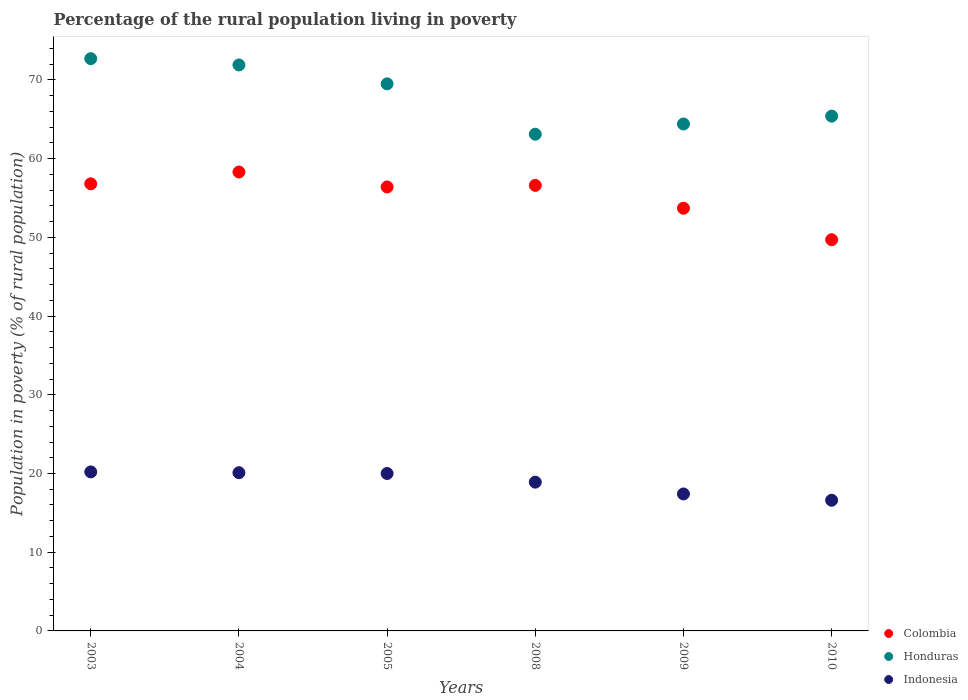How many different coloured dotlines are there?
Your answer should be very brief. 3. Is the number of dotlines equal to the number of legend labels?
Your response must be concise. Yes. Across all years, what is the maximum percentage of the rural population living in poverty in Colombia?
Keep it short and to the point. 58.3. Across all years, what is the minimum percentage of the rural population living in poverty in Colombia?
Ensure brevity in your answer.  49.7. In which year was the percentage of the rural population living in poverty in Honduras maximum?
Ensure brevity in your answer.  2003. In which year was the percentage of the rural population living in poverty in Colombia minimum?
Provide a succinct answer. 2010. What is the total percentage of the rural population living in poverty in Indonesia in the graph?
Your answer should be compact. 113.2. What is the difference between the percentage of the rural population living in poverty in Honduras in 2003 and that in 2004?
Offer a very short reply. 0.8. What is the difference between the percentage of the rural population living in poverty in Honduras in 2005 and the percentage of the rural population living in poverty in Indonesia in 2008?
Your answer should be very brief. 50.6. What is the average percentage of the rural population living in poverty in Colombia per year?
Your answer should be compact. 55.25. In the year 2008, what is the difference between the percentage of the rural population living in poverty in Indonesia and percentage of the rural population living in poverty in Colombia?
Keep it short and to the point. -37.7. In how many years, is the percentage of the rural population living in poverty in Honduras greater than 2 %?
Offer a terse response. 6. What is the ratio of the percentage of the rural population living in poverty in Indonesia in 2004 to that in 2009?
Your answer should be compact. 1.16. Is the percentage of the rural population living in poverty in Colombia in 2004 less than that in 2009?
Provide a succinct answer. No. What is the difference between the highest and the second highest percentage of the rural population living in poverty in Honduras?
Your answer should be compact. 0.8. What is the difference between the highest and the lowest percentage of the rural population living in poverty in Colombia?
Keep it short and to the point. 8.6. Is the sum of the percentage of the rural population living in poverty in Colombia in 2004 and 2008 greater than the maximum percentage of the rural population living in poverty in Honduras across all years?
Offer a very short reply. Yes. Is it the case that in every year, the sum of the percentage of the rural population living in poverty in Indonesia and percentage of the rural population living in poverty in Honduras  is greater than the percentage of the rural population living in poverty in Colombia?
Your answer should be compact. Yes. Does the percentage of the rural population living in poverty in Honduras monotonically increase over the years?
Provide a succinct answer. No. Is the percentage of the rural population living in poverty in Indonesia strictly greater than the percentage of the rural population living in poverty in Honduras over the years?
Make the answer very short. No. How many dotlines are there?
Offer a terse response. 3. Does the graph contain any zero values?
Ensure brevity in your answer.  No. Where does the legend appear in the graph?
Your response must be concise. Bottom right. What is the title of the graph?
Give a very brief answer. Percentage of the rural population living in poverty. Does "Albania" appear as one of the legend labels in the graph?
Offer a very short reply. No. What is the label or title of the Y-axis?
Your answer should be compact. Population in poverty (% of rural population). What is the Population in poverty (% of rural population) of Colombia in 2003?
Offer a very short reply. 56.8. What is the Population in poverty (% of rural population) in Honduras in 2003?
Your answer should be very brief. 72.7. What is the Population in poverty (% of rural population) of Indonesia in 2003?
Your response must be concise. 20.2. What is the Population in poverty (% of rural population) in Colombia in 2004?
Make the answer very short. 58.3. What is the Population in poverty (% of rural population) in Honduras in 2004?
Provide a succinct answer. 71.9. What is the Population in poverty (% of rural population) in Indonesia in 2004?
Keep it short and to the point. 20.1. What is the Population in poverty (% of rural population) in Colombia in 2005?
Provide a succinct answer. 56.4. What is the Population in poverty (% of rural population) of Honduras in 2005?
Your answer should be very brief. 69.5. What is the Population in poverty (% of rural population) of Colombia in 2008?
Your answer should be compact. 56.6. What is the Population in poverty (% of rural population) of Honduras in 2008?
Offer a terse response. 63.1. What is the Population in poverty (% of rural population) in Indonesia in 2008?
Your answer should be very brief. 18.9. What is the Population in poverty (% of rural population) in Colombia in 2009?
Provide a short and direct response. 53.7. What is the Population in poverty (% of rural population) in Honduras in 2009?
Keep it short and to the point. 64.4. What is the Population in poverty (% of rural population) in Indonesia in 2009?
Provide a short and direct response. 17.4. What is the Population in poverty (% of rural population) in Colombia in 2010?
Keep it short and to the point. 49.7. What is the Population in poverty (% of rural population) of Honduras in 2010?
Your answer should be very brief. 65.4. Across all years, what is the maximum Population in poverty (% of rural population) of Colombia?
Your response must be concise. 58.3. Across all years, what is the maximum Population in poverty (% of rural population) in Honduras?
Make the answer very short. 72.7. Across all years, what is the maximum Population in poverty (% of rural population) in Indonesia?
Give a very brief answer. 20.2. Across all years, what is the minimum Population in poverty (% of rural population) of Colombia?
Ensure brevity in your answer.  49.7. Across all years, what is the minimum Population in poverty (% of rural population) of Honduras?
Your answer should be very brief. 63.1. What is the total Population in poverty (% of rural population) in Colombia in the graph?
Keep it short and to the point. 331.5. What is the total Population in poverty (% of rural population) in Honduras in the graph?
Provide a short and direct response. 407. What is the total Population in poverty (% of rural population) in Indonesia in the graph?
Keep it short and to the point. 113.2. What is the difference between the Population in poverty (% of rural population) in Honduras in 2003 and that in 2004?
Your answer should be compact. 0.8. What is the difference between the Population in poverty (% of rural population) of Indonesia in 2003 and that in 2004?
Provide a short and direct response. 0.1. What is the difference between the Population in poverty (% of rural population) of Colombia in 2003 and that in 2005?
Offer a very short reply. 0.4. What is the difference between the Population in poverty (% of rural population) of Honduras in 2003 and that in 2005?
Offer a terse response. 3.2. What is the difference between the Population in poverty (% of rural population) of Honduras in 2003 and that in 2009?
Your response must be concise. 8.3. What is the difference between the Population in poverty (% of rural population) of Honduras in 2004 and that in 2005?
Provide a short and direct response. 2.4. What is the difference between the Population in poverty (% of rural population) in Indonesia in 2004 and that in 2005?
Ensure brevity in your answer.  0.1. What is the difference between the Population in poverty (% of rural population) in Colombia in 2004 and that in 2008?
Your answer should be very brief. 1.7. What is the difference between the Population in poverty (% of rural population) in Colombia in 2004 and that in 2009?
Ensure brevity in your answer.  4.6. What is the difference between the Population in poverty (% of rural population) of Indonesia in 2004 and that in 2010?
Your answer should be very brief. 3.5. What is the difference between the Population in poverty (% of rural population) in Honduras in 2005 and that in 2008?
Provide a succinct answer. 6.4. What is the difference between the Population in poverty (% of rural population) of Indonesia in 2005 and that in 2008?
Make the answer very short. 1.1. What is the difference between the Population in poverty (% of rural population) of Honduras in 2005 and that in 2009?
Your response must be concise. 5.1. What is the difference between the Population in poverty (% of rural population) of Indonesia in 2005 and that in 2009?
Offer a very short reply. 2.6. What is the difference between the Population in poverty (% of rural population) in Colombia in 2005 and that in 2010?
Ensure brevity in your answer.  6.7. What is the difference between the Population in poverty (% of rural population) in Honduras in 2005 and that in 2010?
Provide a succinct answer. 4.1. What is the difference between the Population in poverty (% of rural population) in Honduras in 2008 and that in 2010?
Offer a very short reply. -2.3. What is the difference between the Population in poverty (% of rural population) in Colombia in 2009 and that in 2010?
Your answer should be compact. 4. What is the difference between the Population in poverty (% of rural population) of Colombia in 2003 and the Population in poverty (% of rural population) of Honduras in 2004?
Give a very brief answer. -15.1. What is the difference between the Population in poverty (% of rural population) in Colombia in 2003 and the Population in poverty (% of rural population) in Indonesia in 2004?
Ensure brevity in your answer.  36.7. What is the difference between the Population in poverty (% of rural population) in Honduras in 2003 and the Population in poverty (% of rural population) in Indonesia in 2004?
Make the answer very short. 52.6. What is the difference between the Population in poverty (% of rural population) in Colombia in 2003 and the Population in poverty (% of rural population) in Honduras in 2005?
Make the answer very short. -12.7. What is the difference between the Population in poverty (% of rural population) in Colombia in 2003 and the Population in poverty (% of rural population) in Indonesia in 2005?
Offer a terse response. 36.8. What is the difference between the Population in poverty (% of rural population) in Honduras in 2003 and the Population in poverty (% of rural population) in Indonesia in 2005?
Ensure brevity in your answer.  52.7. What is the difference between the Population in poverty (% of rural population) of Colombia in 2003 and the Population in poverty (% of rural population) of Indonesia in 2008?
Make the answer very short. 37.9. What is the difference between the Population in poverty (% of rural population) in Honduras in 2003 and the Population in poverty (% of rural population) in Indonesia in 2008?
Keep it short and to the point. 53.8. What is the difference between the Population in poverty (% of rural population) in Colombia in 2003 and the Population in poverty (% of rural population) in Indonesia in 2009?
Provide a short and direct response. 39.4. What is the difference between the Population in poverty (% of rural population) in Honduras in 2003 and the Population in poverty (% of rural population) in Indonesia in 2009?
Keep it short and to the point. 55.3. What is the difference between the Population in poverty (% of rural population) of Colombia in 2003 and the Population in poverty (% of rural population) of Honduras in 2010?
Keep it short and to the point. -8.6. What is the difference between the Population in poverty (% of rural population) of Colombia in 2003 and the Population in poverty (% of rural population) of Indonesia in 2010?
Provide a short and direct response. 40.2. What is the difference between the Population in poverty (% of rural population) in Honduras in 2003 and the Population in poverty (% of rural population) in Indonesia in 2010?
Keep it short and to the point. 56.1. What is the difference between the Population in poverty (% of rural population) of Colombia in 2004 and the Population in poverty (% of rural population) of Indonesia in 2005?
Your response must be concise. 38.3. What is the difference between the Population in poverty (% of rural population) in Honduras in 2004 and the Population in poverty (% of rural population) in Indonesia in 2005?
Provide a succinct answer. 51.9. What is the difference between the Population in poverty (% of rural population) in Colombia in 2004 and the Population in poverty (% of rural population) in Honduras in 2008?
Provide a succinct answer. -4.8. What is the difference between the Population in poverty (% of rural population) in Colombia in 2004 and the Population in poverty (% of rural population) in Indonesia in 2008?
Your answer should be very brief. 39.4. What is the difference between the Population in poverty (% of rural population) in Colombia in 2004 and the Population in poverty (% of rural population) in Indonesia in 2009?
Offer a terse response. 40.9. What is the difference between the Population in poverty (% of rural population) of Honduras in 2004 and the Population in poverty (% of rural population) of Indonesia in 2009?
Provide a succinct answer. 54.5. What is the difference between the Population in poverty (% of rural population) of Colombia in 2004 and the Population in poverty (% of rural population) of Indonesia in 2010?
Your response must be concise. 41.7. What is the difference between the Population in poverty (% of rural population) in Honduras in 2004 and the Population in poverty (% of rural population) in Indonesia in 2010?
Give a very brief answer. 55.3. What is the difference between the Population in poverty (% of rural population) of Colombia in 2005 and the Population in poverty (% of rural population) of Indonesia in 2008?
Your answer should be very brief. 37.5. What is the difference between the Population in poverty (% of rural population) in Honduras in 2005 and the Population in poverty (% of rural population) in Indonesia in 2008?
Provide a short and direct response. 50.6. What is the difference between the Population in poverty (% of rural population) in Colombia in 2005 and the Population in poverty (% of rural population) in Honduras in 2009?
Make the answer very short. -8. What is the difference between the Population in poverty (% of rural population) of Colombia in 2005 and the Population in poverty (% of rural population) of Indonesia in 2009?
Your answer should be compact. 39. What is the difference between the Population in poverty (% of rural population) in Honduras in 2005 and the Population in poverty (% of rural population) in Indonesia in 2009?
Provide a succinct answer. 52.1. What is the difference between the Population in poverty (% of rural population) in Colombia in 2005 and the Population in poverty (% of rural population) in Indonesia in 2010?
Give a very brief answer. 39.8. What is the difference between the Population in poverty (% of rural population) of Honduras in 2005 and the Population in poverty (% of rural population) of Indonesia in 2010?
Your response must be concise. 52.9. What is the difference between the Population in poverty (% of rural population) in Colombia in 2008 and the Population in poverty (% of rural population) in Indonesia in 2009?
Make the answer very short. 39.2. What is the difference between the Population in poverty (% of rural population) in Honduras in 2008 and the Population in poverty (% of rural population) in Indonesia in 2009?
Provide a succinct answer. 45.7. What is the difference between the Population in poverty (% of rural population) in Colombia in 2008 and the Population in poverty (% of rural population) in Honduras in 2010?
Your answer should be compact. -8.8. What is the difference between the Population in poverty (% of rural population) in Honduras in 2008 and the Population in poverty (% of rural population) in Indonesia in 2010?
Your answer should be very brief. 46.5. What is the difference between the Population in poverty (% of rural population) of Colombia in 2009 and the Population in poverty (% of rural population) of Indonesia in 2010?
Your answer should be very brief. 37.1. What is the difference between the Population in poverty (% of rural population) of Honduras in 2009 and the Population in poverty (% of rural population) of Indonesia in 2010?
Offer a terse response. 47.8. What is the average Population in poverty (% of rural population) in Colombia per year?
Your answer should be compact. 55.25. What is the average Population in poverty (% of rural population) of Honduras per year?
Offer a terse response. 67.83. What is the average Population in poverty (% of rural population) in Indonesia per year?
Offer a terse response. 18.87. In the year 2003, what is the difference between the Population in poverty (% of rural population) in Colombia and Population in poverty (% of rural population) in Honduras?
Your answer should be compact. -15.9. In the year 2003, what is the difference between the Population in poverty (% of rural population) of Colombia and Population in poverty (% of rural population) of Indonesia?
Your answer should be very brief. 36.6. In the year 2003, what is the difference between the Population in poverty (% of rural population) in Honduras and Population in poverty (% of rural population) in Indonesia?
Make the answer very short. 52.5. In the year 2004, what is the difference between the Population in poverty (% of rural population) of Colombia and Population in poverty (% of rural population) of Indonesia?
Provide a short and direct response. 38.2. In the year 2004, what is the difference between the Population in poverty (% of rural population) of Honduras and Population in poverty (% of rural population) of Indonesia?
Your response must be concise. 51.8. In the year 2005, what is the difference between the Population in poverty (% of rural population) of Colombia and Population in poverty (% of rural population) of Indonesia?
Your answer should be compact. 36.4. In the year 2005, what is the difference between the Population in poverty (% of rural population) in Honduras and Population in poverty (% of rural population) in Indonesia?
Your answer should be compact. 49.5. In the year 2008, what is the difference between the Population in poverty (% of rural population) in Colombia and Population in poverty (% of rural population) in Indonesia?
Make the answer very short. 37.7. In the year 2008, what is the difference between the Population in poverty (% of rural population) of Honduras and Population in poverty (% of rural population) of Indonesia?
Your answer should be compact. 44.2. In the year 2009, what is the difference between the Population in poverty (% of rural population) in Colombia and Population in poverty (% of rural population) in Indonesia?
Keep it short and to the point. 36.3. In the year 2010, what is the difference between the Population in poverty (% of rural population) in Colombia and Population in poverty (% of rural population) in Honduras?
Offer a terse response. -15.7. In the year 2010, what is the difference between the Population in poverty (% of rural population) in Colombia and Population in poverty (% of rural population) in Indonesia?
Make the answer very short. 33.1. In the year 2010, what is the difference between the Population in poverty (% of rural population) of Honduras and Population in poverty (% of rural population) of Indonesia?
Make the answer very short. 48.8. What is the ratio of the Population in poverty (% of rural population) of Colombia in 2003 to that in 2004?
Keep it short and to the point. 0.97. What is the ratio of the Population in poverty (% of rural population) of Honduras in 2003 to that in 2004?
Offer a terse response. 1.01. What is the ratio of the Population in poverty (% of rural population) in Colombia in 2003 to that in 2005?
Ensure brevity in your answer.  1.01. What is the ratio of the Population in poverty (% of rural population) of Honduras in 2003 to that in 2005?
Offer a very short reply. 1.05. What is the ratio of the Population in poverty (% of rural population) in Honduras in 2003 to that in 2008?
Your answer should be very brief. 1.15. What is the ratio of the Population in poverty (% of rural population) of Indonesia in 2003 to that in 2008?
Give a very brief answer. 1.07. What is the ratio of the Population in poverty (% of rural population) in Colombia in 2003 to that in 2009?
Your answer should be very brief. 1.06. What is the ratio of the Population in poverty (% of rural population) in Honduras in 2003 to that in 2009?
Your response must be concise. 1.13. What is the ratio of the Population in poverty (% of rural population) in Indonesia in 2003 to that in 2009?
Ensure brevity in your answer.  1.16. What is the ratio of the Population in poverty (% of rural population) of Honduras in 2003 to that in 2010?
Offer a very short reply. 1.11. What is the ratio of the Population in poverty (% of rural population) in Indonesia in 2003 to that in 2010?
Ensure brevity in your answer.  1.22. What is the ratio of the Population in poverty (% of rural population) in Colombia in 2004 to that in 2005?
Your answer should be very brief. 1.03. What is the ratio of the Population in poverty (% of rural population) of Honduras in 2004 to that in 2005?
Your answer should be compact. 1.03. What is the ratio of the Population in poverty (% of rural population) of Indonesia in 2004 to that in 2005?
Keep it short and to the point. 1. What is the ratio of the Population in poverty (% of rural population) of Colombia in 2004 to that in 2008?
Give a very brief answer. 1.03. What is the ratio of the Population in poverty (% of rural population) in Honduras in 2004 to that in 2008?
Your answer should be compact. 1.14. What is the ratio of the Population in poverty (% of rural population) in Indonesia in 2004 to that in 2008?
Ensure brevity in your answer.  1.06. What is the ratio of the Population in poverty (% of rural population) in Colombia in 2004 to that in 2009?
Your answer should be compact. 1.09. What is the ratio of the Population in poverty (% of rural population) in Honduras in 2004 to that in 2009?
Give a very brief answer. 1.12. What is the ratio of the Population in poverty (% of rural population) of Indonesia in 2004 to that in 2009?
Provide a succinct answer. 1.16. What is the ratio of the Population in poverty (% of rural population) in Colombia in 2004 to that in 2010?
Keep it short and to the point. 1.17. What is the ratio of the Population in poverty (% of rural population) in Honduras in 2004 to that in 2010?
Ensure brevity in your answer.  1.1. What is the ratio of the Population in poverty (% of rural population) in Indonesia in 2004 to that in 2010?
Give a very brief answer. 1.21. What is the ratio of the Population in poverty (% of rural population) in Colombia in 2005 to that in 2008?
Provide a succinct answer. 1. What is the ratio of the Population in poverty (% of rural population) in Honduras in 2005 to that in 2008?
Provide a succinct answer. 1.1. What is the ratio of the Population in poverty (% of rural population) of Indonesia in 2005 to that in 2008?
Your response must be concise. 1.06. What is the ratio of the Population in poverty (% of rural population) in Colombia in 2005 to that in 2009?
Your answer should be very brief. 1.05. What is the ratio of the Population in poverty (% of rural population) in Honduras in 2005 to that in 2009?
Give a very brief answer. 1.08. What is the ratio of the Population in poverty (% of rural population) of Indonesia in 2005 to that in 2009?
Keep it short and to the point. 1.15. What is the ratio of the Population in poverty (% of rural population) in Colombia in 2005 to that in 2010?
Offer a very short reply. 1.13. What is the ratio of the Population in poverty (% of rural population) in Honduras in 2005 to that in 2010?
Provide a short and direct response. 1.06. What is the ratio of the Population in poverty (% of rural population) in Indonesia in 2005 to that in 2010?
Ensure brevity in your answer.  1.2. What is the ratio of the Population in poverty (% of rural population) of Colombia in 2008 to that in 2009?
Offer a very short reply. 1.05. What is the ratio of the Population in poverty (% of rural population) in Honduras in 2008 to that in 2009?
Give a very brief answer. 0.98. What is the ratio of the Population in poverty (% of rural population) in Indonesia in 2008 to that in 2009?
Provide a succinct answer. 1.09. What is the ratio of the Population in poverty (% of rural population) of Colombia in 2008 to that in 2010?
Offer a very short reply. 1.14. What is the ratio of the Population in poverty (% of rural population) of Honduras in 2008 to that in 2010?
Offer a terse response. 0.96. What is the ratio of the Population in poverty (% of rural population) of Indonesia in 2008 to that in 2010?
Your response must be concise. 1.14. What is the ratio of the Population in poverty (% of rural population) in Colombia in 2009 to that in 2010?
Give a very brief answer. 1.08. What is the ratio of the Population in poverty (% of rural population) in Honduras in 2009 to that in 2010?
Provide a succinct answer. 0.98. What is the ratio of the Population in poverty (% of rural population) in Indonesia in 2009 to that in 2010?
Make the answer very short. 1.05. What is the difference between the highest and the second highest Population in poverty (% of rural population) of Colombia?
Give a very brief answer. 1.5. What is the difference between the highest and the second highest Population in poverty (% of rural population) in Indonesia?
Your response must be concise. 0.1. What is the difference between the highest and the lowest Population in poverty (% of rural population) of Honduras?
Provide a succinct answer. 9.6. What is the difference between the highest and the lowest Population in poverty (% of rural population) in Indonesia?
Ensure brevity in your answer.  3.6. 